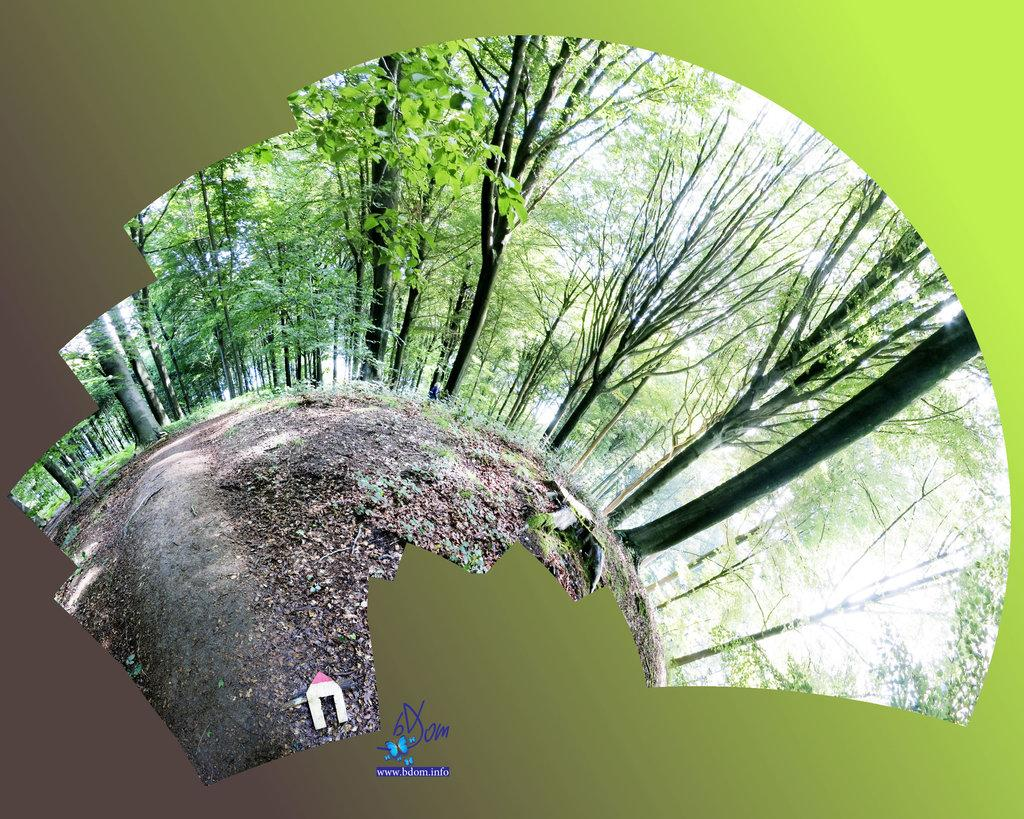What type of vegetation can be seen in the image? There are trees in the image. What is the shape of the ground in the image? The ground appears to be round in shape. What is the aftermath of the plot in the image? There is no plot or storyline depicted in the image, so it's not possible to determine the aftermath. 